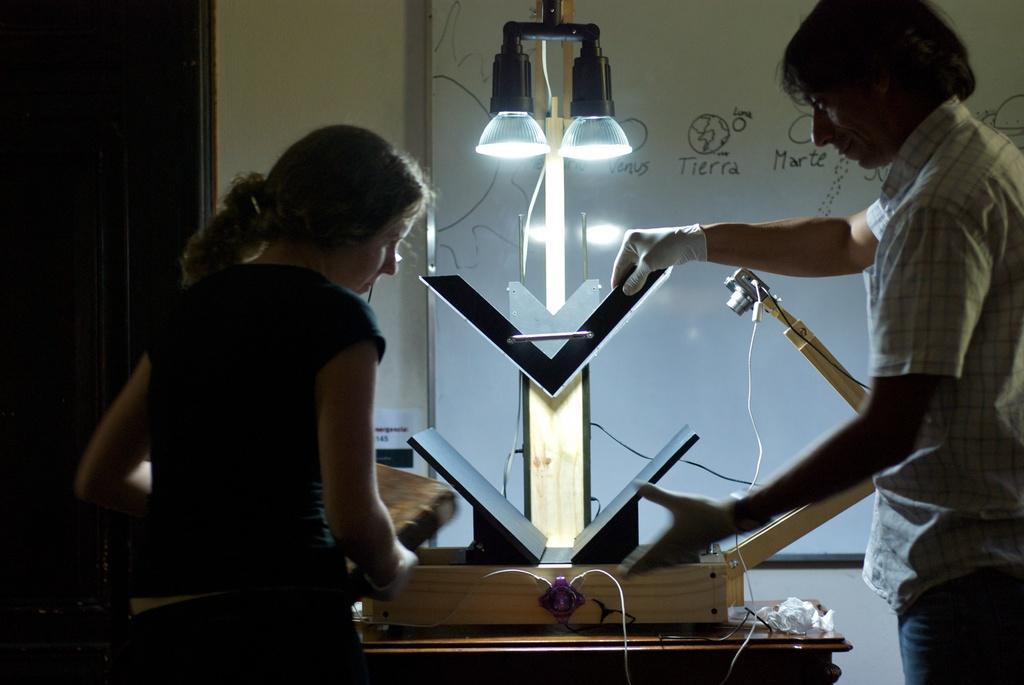In one or two sentences, can you explain what this image depicts? In this image in the middle we can see an electronic object. And we can see a man and a woman standing. And we can see the whiteboard and the wall. 